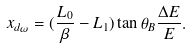<formula> <loc_0><loc_0><loc_500><loc_500>x _ { d \omega } = ( \frac { L _ { 0 } } { \beta } - L _ { 1 } ) \tan \theta _ { B } \frac { \Delta E } { E } .</formula> 